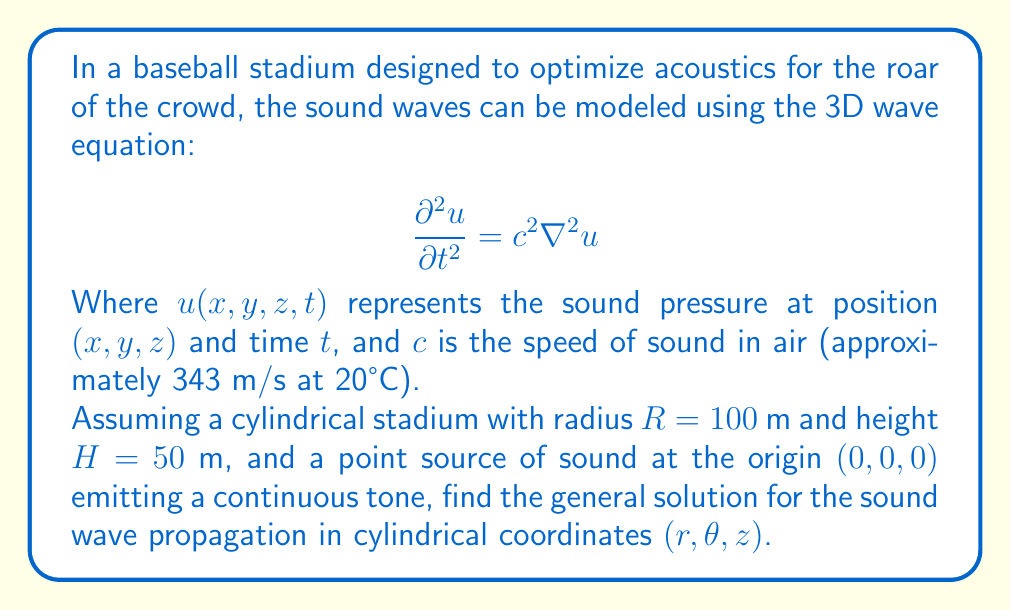Show me your answer to this math problem. To solve this problem, we'll follow these steps:

1) First, we need to express the 3D wave equation in cylindrical coordinates:

   $$\frac{\partial^2 u}{\partial t^2} = c^2 \left(\frac{\partial^2 u}{\partial r^2} + \frac{1}{r}\frac{\partial u}{\partial r} + \frac{1}{r^2}\frac{\partial^2 u}{\partial \theta^2} + \frac{\partial^2 u}{\partial z^2}\right)$$

2) Given the cylindrical symmetry of the stadium and the point source at the origin, we can assume that the solution doesn't depend on $\theta$. This simplifies our equation to:

   $$\frac{\partial^2 u}{\partial t^2} = c^2 \left(\frac{\partial^2 u}{\partial r^2} + \frac{1}{r}\frac{\partial u}{\partial r} + \frac{\partial^2 u}{\partial z^2}\right)$$

3) For a continuous tone, we can assume a harmonic time dependence:

   $$u(r,z,t) = \psi(r,z)e^{i\omega t}$$

   where $\omega$ is the angular frequency of the sound.

4) Substituting this into our simplified wave equation:

   $$-\omega^2\psi e^{i\omega t} = c^2 \left(\frac{\partial^2 \psi}{\partial r^2} + \frac{1}{r}\frac{\partial \psi}{\partial r} + \frac{\partial^2 \psi}{\partial z^2}\right)e^{i\omega t}$$

5) Cancelling $e^{i\omega t}$ and rearranging:

   $$\frac{\partial^2 \psi}{\partial r^2} + \frac{1}{r}\frac{\partial \psi}{\partial r} + \frac{\partial^2 \psi}{\partial z^2} + k^2\psi = 0$$

   where $k = \frac{\omega}{c}$ is the wave number.

6) This equation can be solved using separation of variables. Let $\psi(r,z) = R(r)Z(z)$. Substituting and dividing by $RZ$:

   $$\frac{1}{R}\left(\frac{d^2R}{dr^2} + \frac{1}{r}\frac{dR}{dr}\right) + \frac{1}{Z}\frac{d^2Z}{dz^2} + k^2 = 0$$

7) For this to be true for all $r$ and $z$, each part must equal a constant. Let's call the constant for the $Z$ part $-\alpha^2$:

   $$\frac{1}{Z}\frac{d^2Z}{dz^2} = -\alpha^2$$
   $$\frac{d^2Z}{dz^2} + \alpha^2Z = 0$$

   This has the general solution:
   $$Z(z) = A\cos(\alpha z) + B\sin(\alpha z)$$

8) For the $R$ part:

   $$\frac{d^2R}{dr^2} + \frac{1}{r}\frac{dR}{dr} + (\beta^2)R = 0$$

   where $\beta^2 = k^2 - \alpha^2$. This is Bessel's equation of order 0, with the general solution:

   $$R(r) = CJ_0(\beta r) + DY_0(\beta r)$$

   where $J_0$ and $Y_0$ are Bessel functions of the first and second kind, respectively.

9) Combining all parts, the general solution is:

   $$u(r,z,t) = [CJ_0(\beta r) + DY_0(\beta r)][A\cos(\alpha z) + B\sin(\alpha z)]e^{i\omega t}$$

   where $A$, $B$, $C$, and $D$ are constants determined by boundary conditions, and $\alpha^2 + \beta^2 = k^2 = (\frac{\omega}{c})^2$.
Answer: $u(r,z,t) = [CJ_0(\beta r) + DY_0(\beta r)][A\cos(\alpha z) + B\sin(\alpha z)]e^{i\omega t}$, where $\alpha^2 + \beta^2 = (\frac{\omega}{c})^2$ 